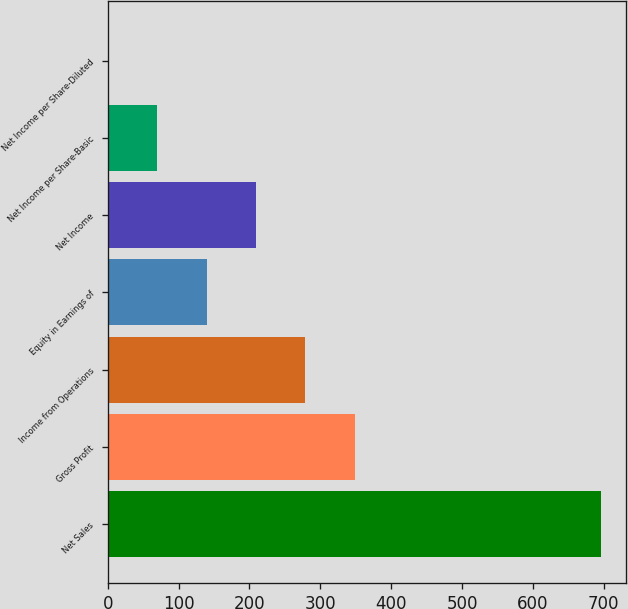Convert chart. <chart><loc_0><loc_0><loc_500><loc_500><bar_chart><fcel>Net Sales<fcel>Gross Profit<fcel>Income from Operations<fcel>Equity in Earnings of<fcel>Net Income<fcel>Net Income per Share-Basic<fcel>Net Income per Share-Diluted<nl><fcel>696.4<fcel>348.46<fcel>278.88<fcel>139.72<fcel>209.3<fcel>70.14<fcel>0.56<nl></chart> 